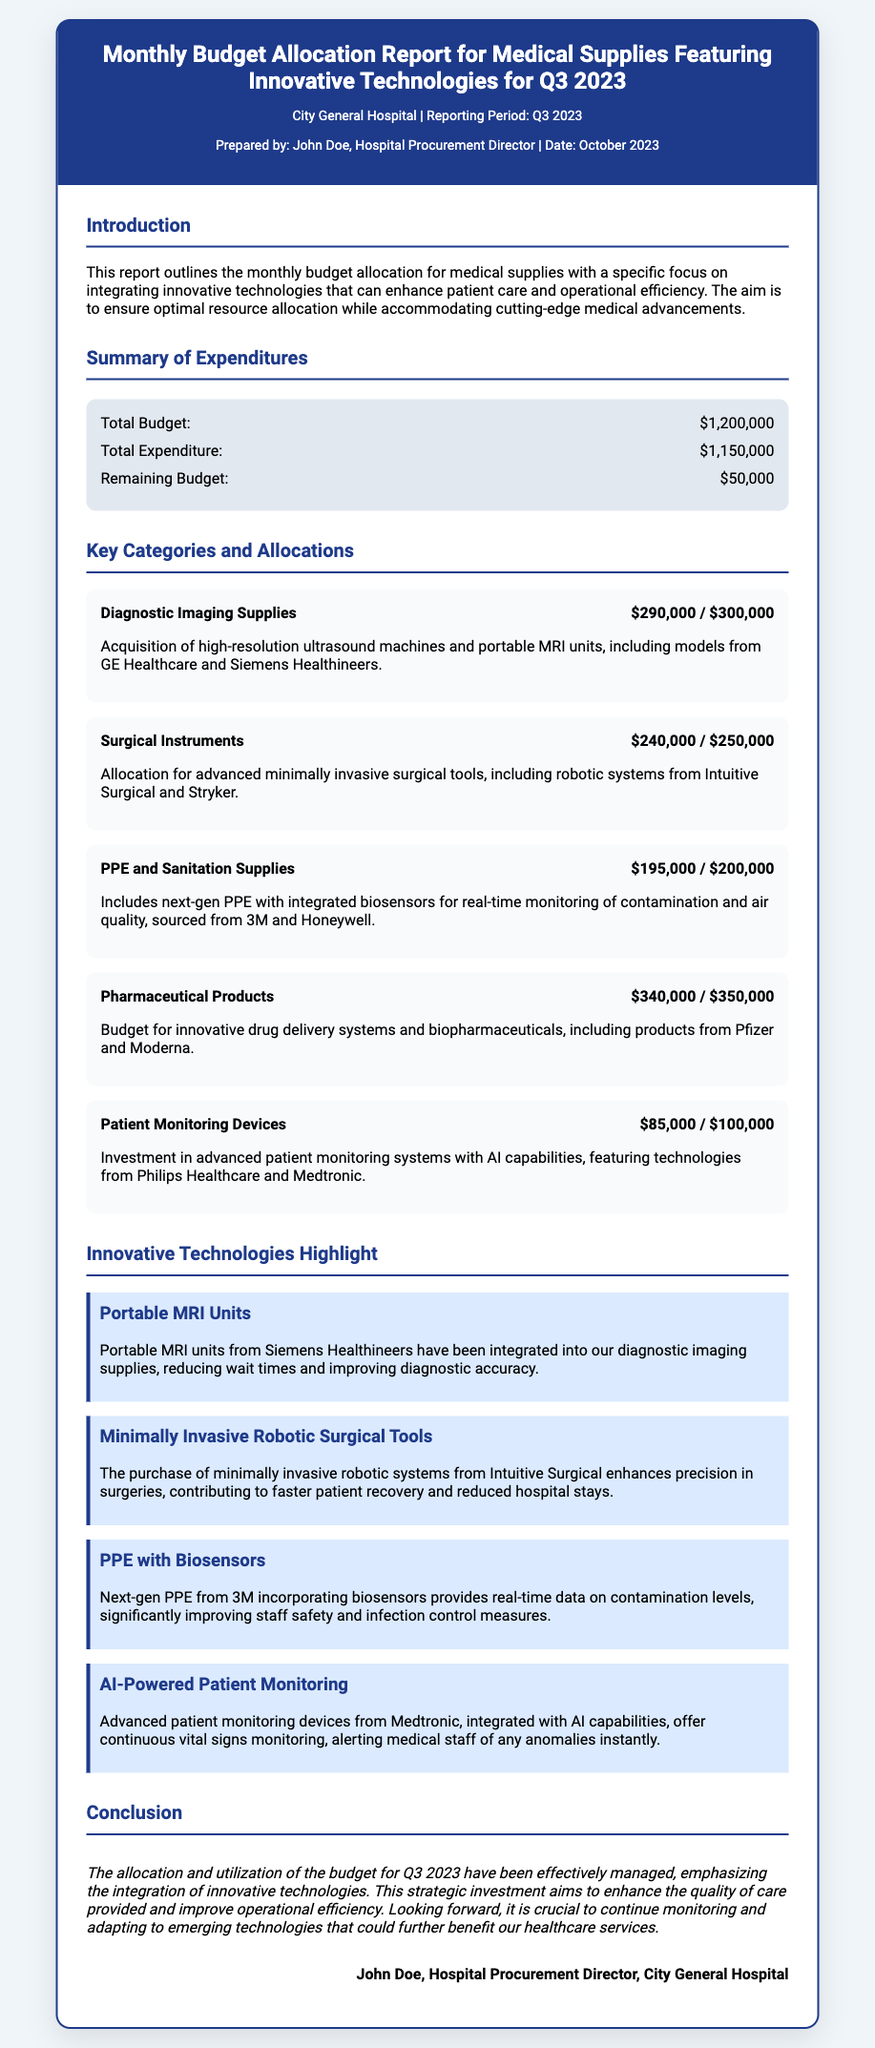what is the total budget? The total budget outlined in the report is $1,200,000.
Answer: $1,200,000 who prepared the report? The report was prepared by John Doe, the Hospital Procurement Director.
Answer: John Doe what is the remaining budget? The document states the remaining budget as $50,000.
Answer: $50,000 what category has the highest expenditure? The category with the highest expenditure is Pharmaceutical Products, with $340,000 allocated.
Answer: Pharmaceutical Products which innovative technology is highlighted for patient monitoring? The highlighted technology for patient monitoring is AI-Powered Patient Monitoring.
Answer: AI-Powered Patient Monitoring how much was allocated for Surgical Instruments? The allocation for Surgical Instruments is $240,000 out of a total of $250,000.
Answer: $240,000 what innovative technology is designed for real-time monitoring? The innovative technology designed for real-time monitoring is PPE with Biosensors.
Answer: PPE with Biosensors what was the total expenditure for Q3 2023? The total expenditure mentioned in the report is $1,150,000.
Answer: $1,150,000 what is the focus of this budget allocation report? The report focuses on integrating innovative technologies that enhance patient care and operational efficiency.
Answer: integrating innovative technologies 